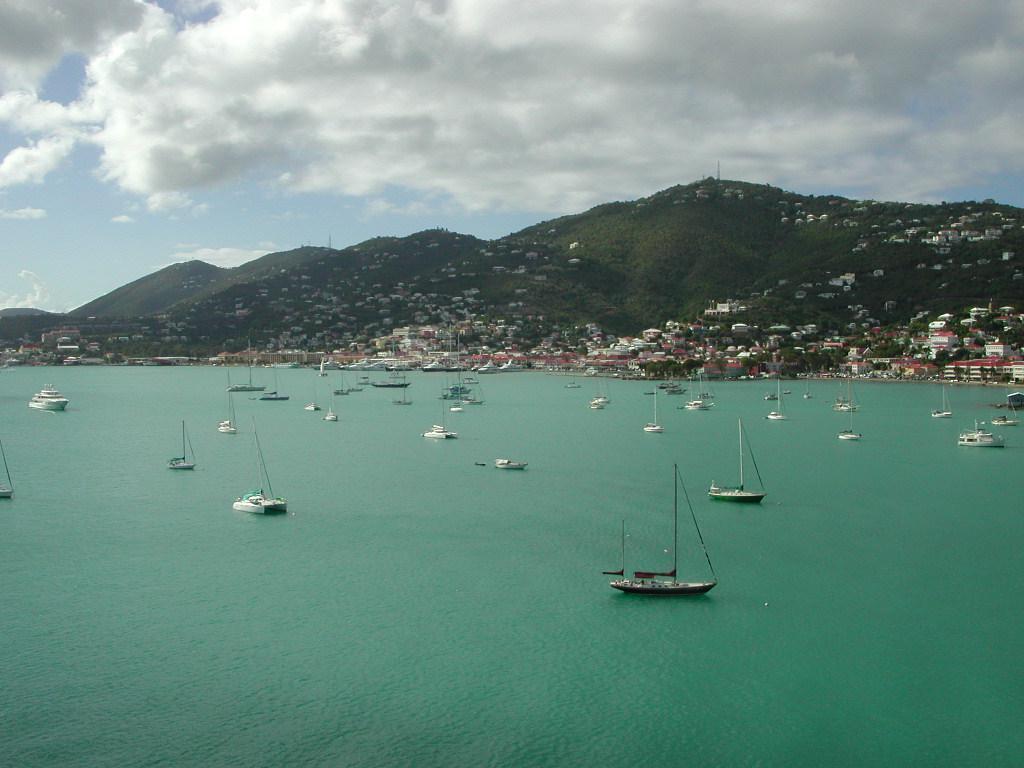How would you summarize this image in a sentence or two? In this picture there are boats in the center of the image on the water and there are houses and trees in the background area of the image. 